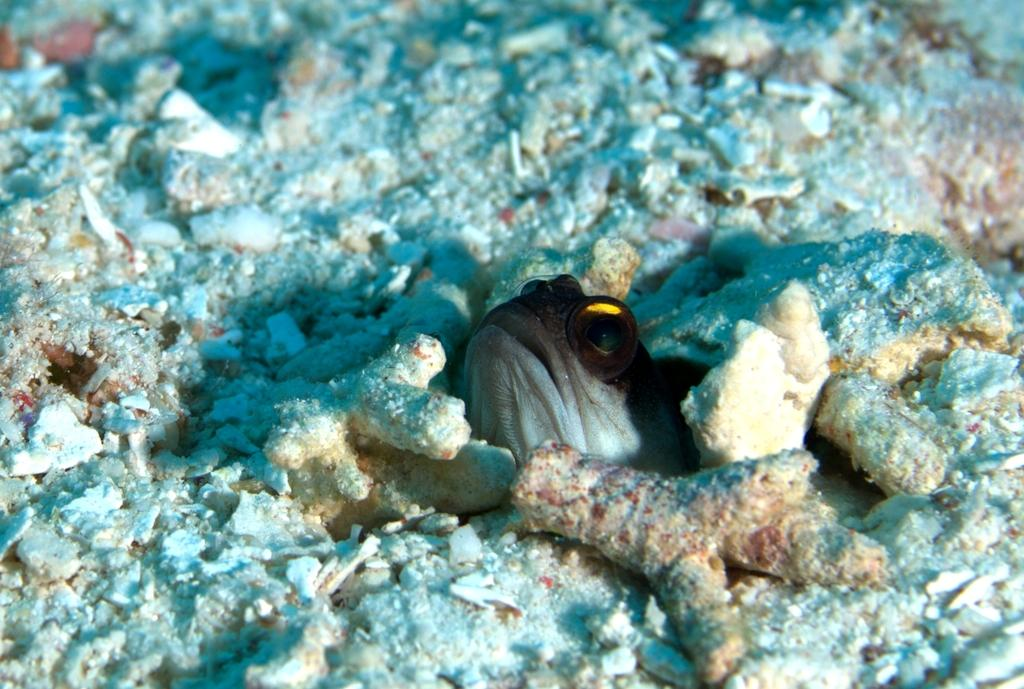What type of animal can be seen in the image? There is a fish in the image. What else can be seen in the image besides the fish? There are corals in the image. What type of statement is being made by the person sitting on the chair in the image? There is no person sitting on a chair in the image; it only features a fish and corals. 